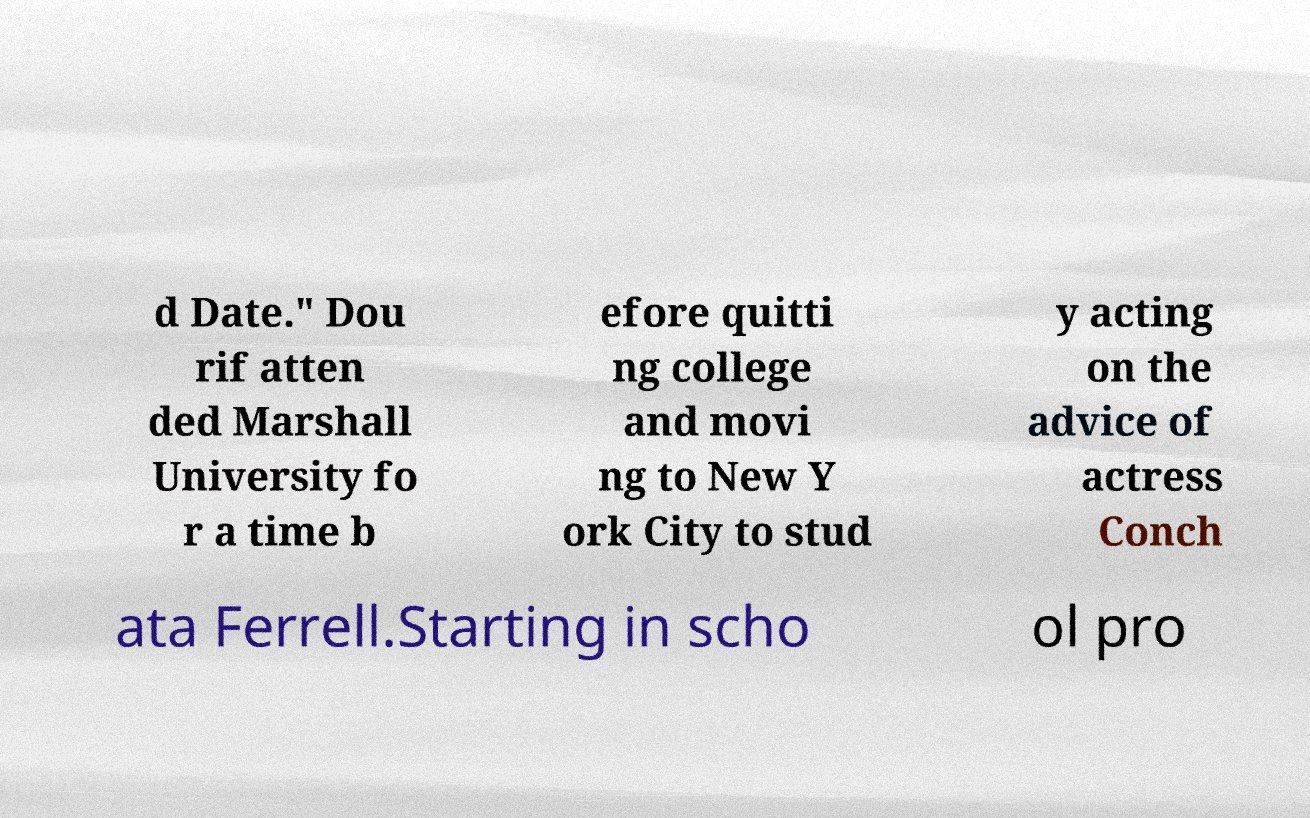Please identify and transcribe the text found in this image. d Date." Dou rif atten ded Marshall University fo r a time b efore quitti ng college and movi ng to New Y ork City to stud y acting on the advice of actress Conch ata Ferrell.Starting in scho ol pro 